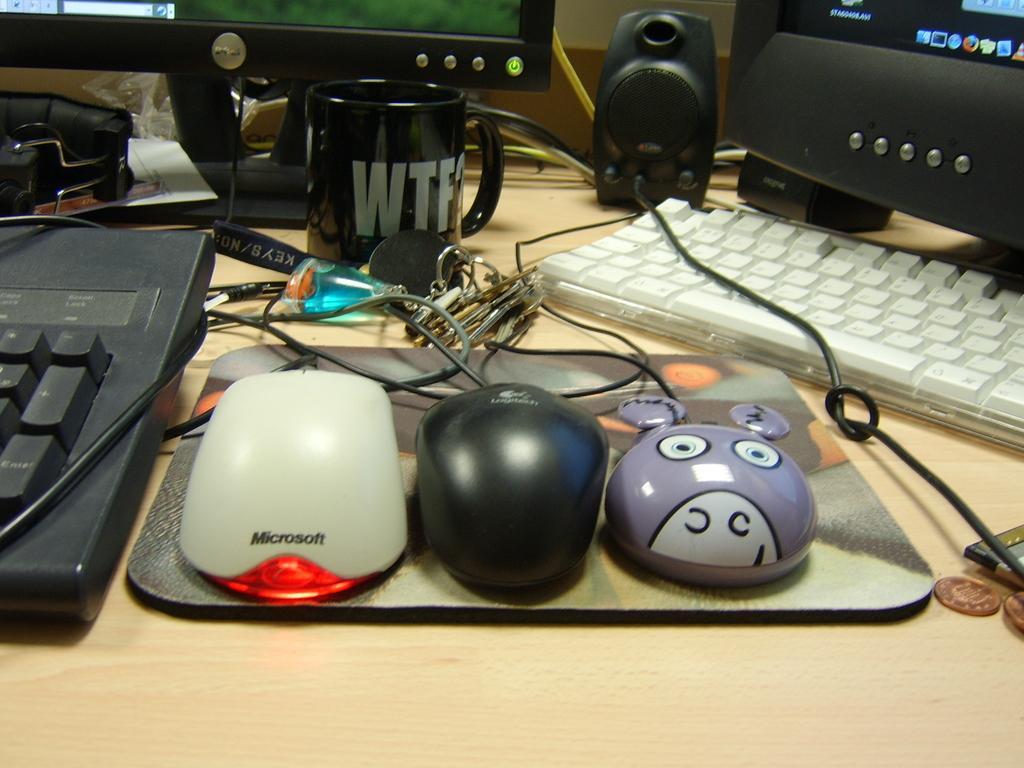How would you summarize this image in a sentence or two? This picture seems to be clicked inside. In the foreground there is a wooden table on the top of which we can see a mouse pad, mouses, keyboards, monitors, mug, speaker and some other items are placed. In the background we can see the cables. 